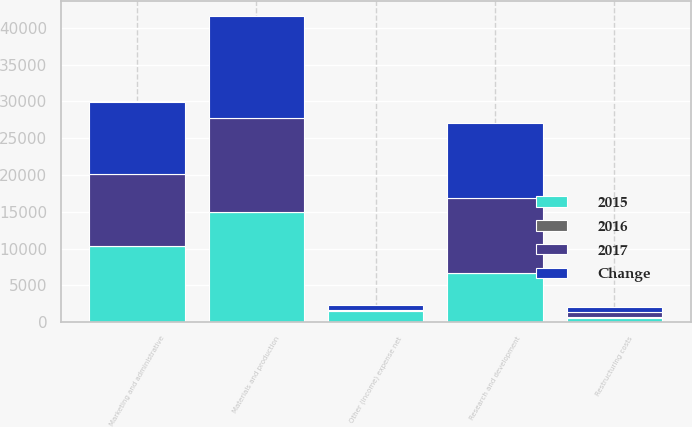Convert chart. <chart><loc_0><loc_0><loc_500><loc_500><stacked_bar_chart><ecel><fcel>Materials and production<fcel>Marketing and administrative<fcel>Research and development<fcel>Restructuring costs<fcel>Other (income) expense net<nl><fcel>2017<fcel>12775<fcel>9830<fcel>10208<fcel>776<fcel>12<nl><fcel>2016<fcel>8<fcel>1<fcel>1<fcel>19<fcel>98<nl><fcel>Change<fcel>13891<fcel>9762<fcel>10124<fcel>651<fcel>720<nl><fcel>2015<fcel>14934<fcel>10313<fcel>6704<fcel>619<fcel>1527<nl></chart> 